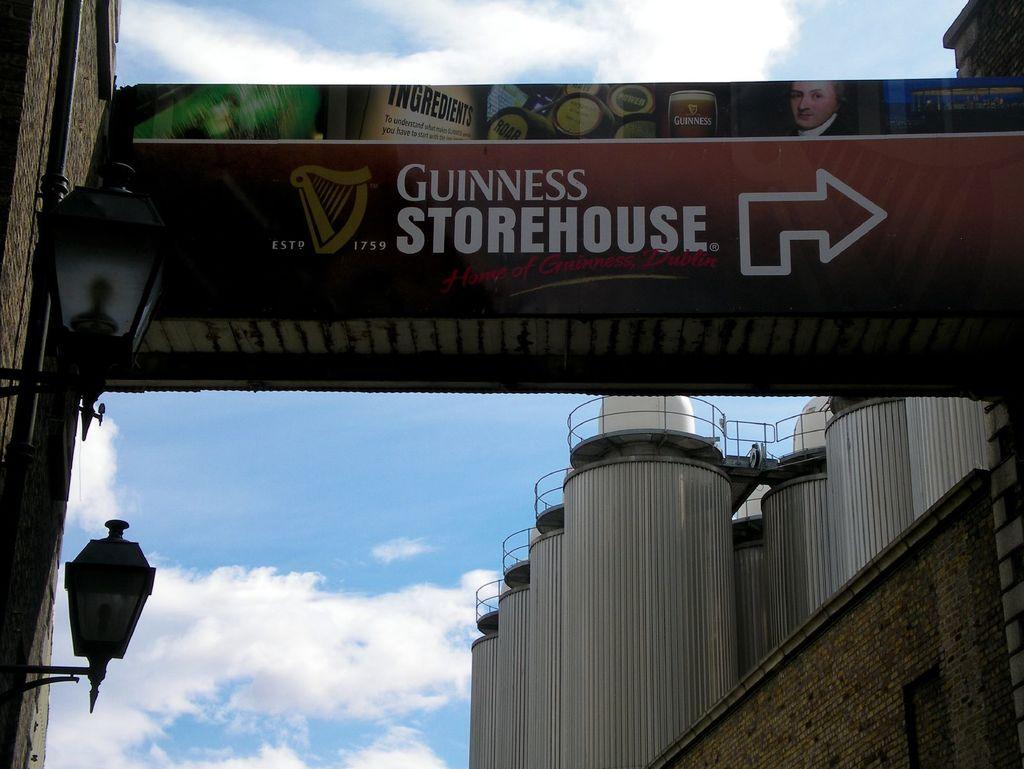<image>
Summarize the visual content of the image. The sign hanging next to a building informs that the Guinness Storehouse is to the right. 